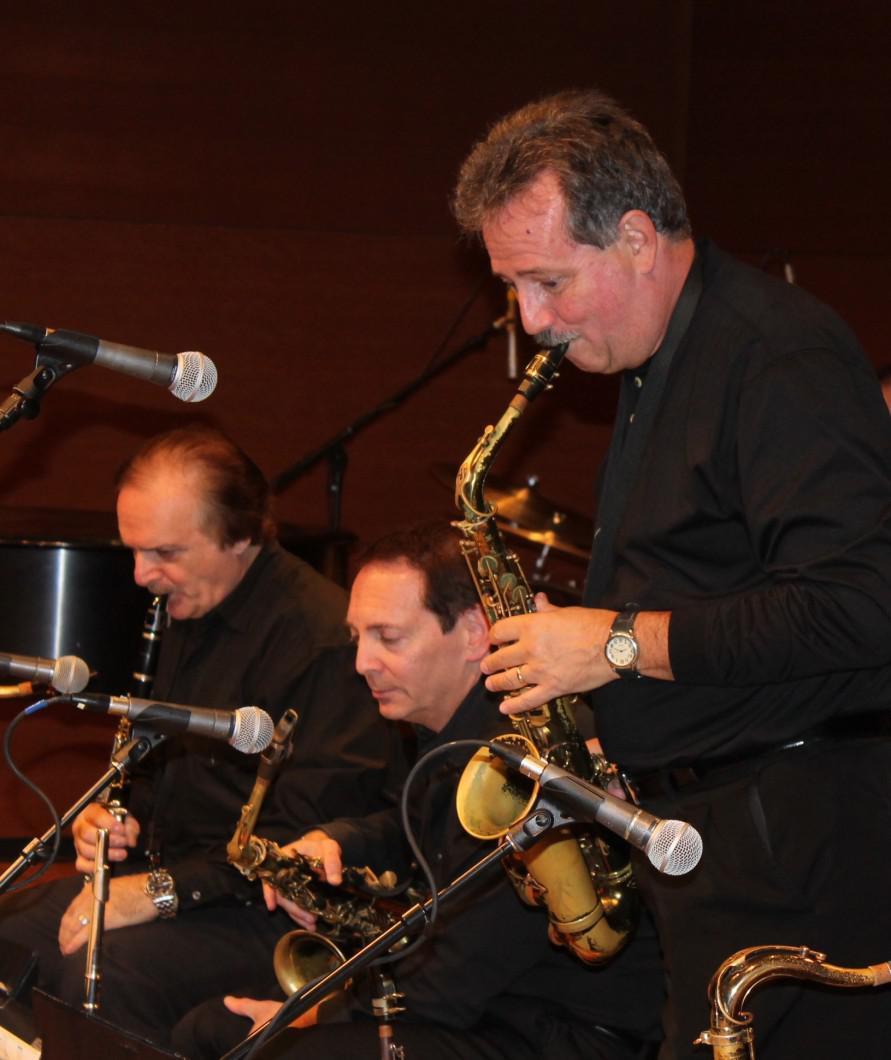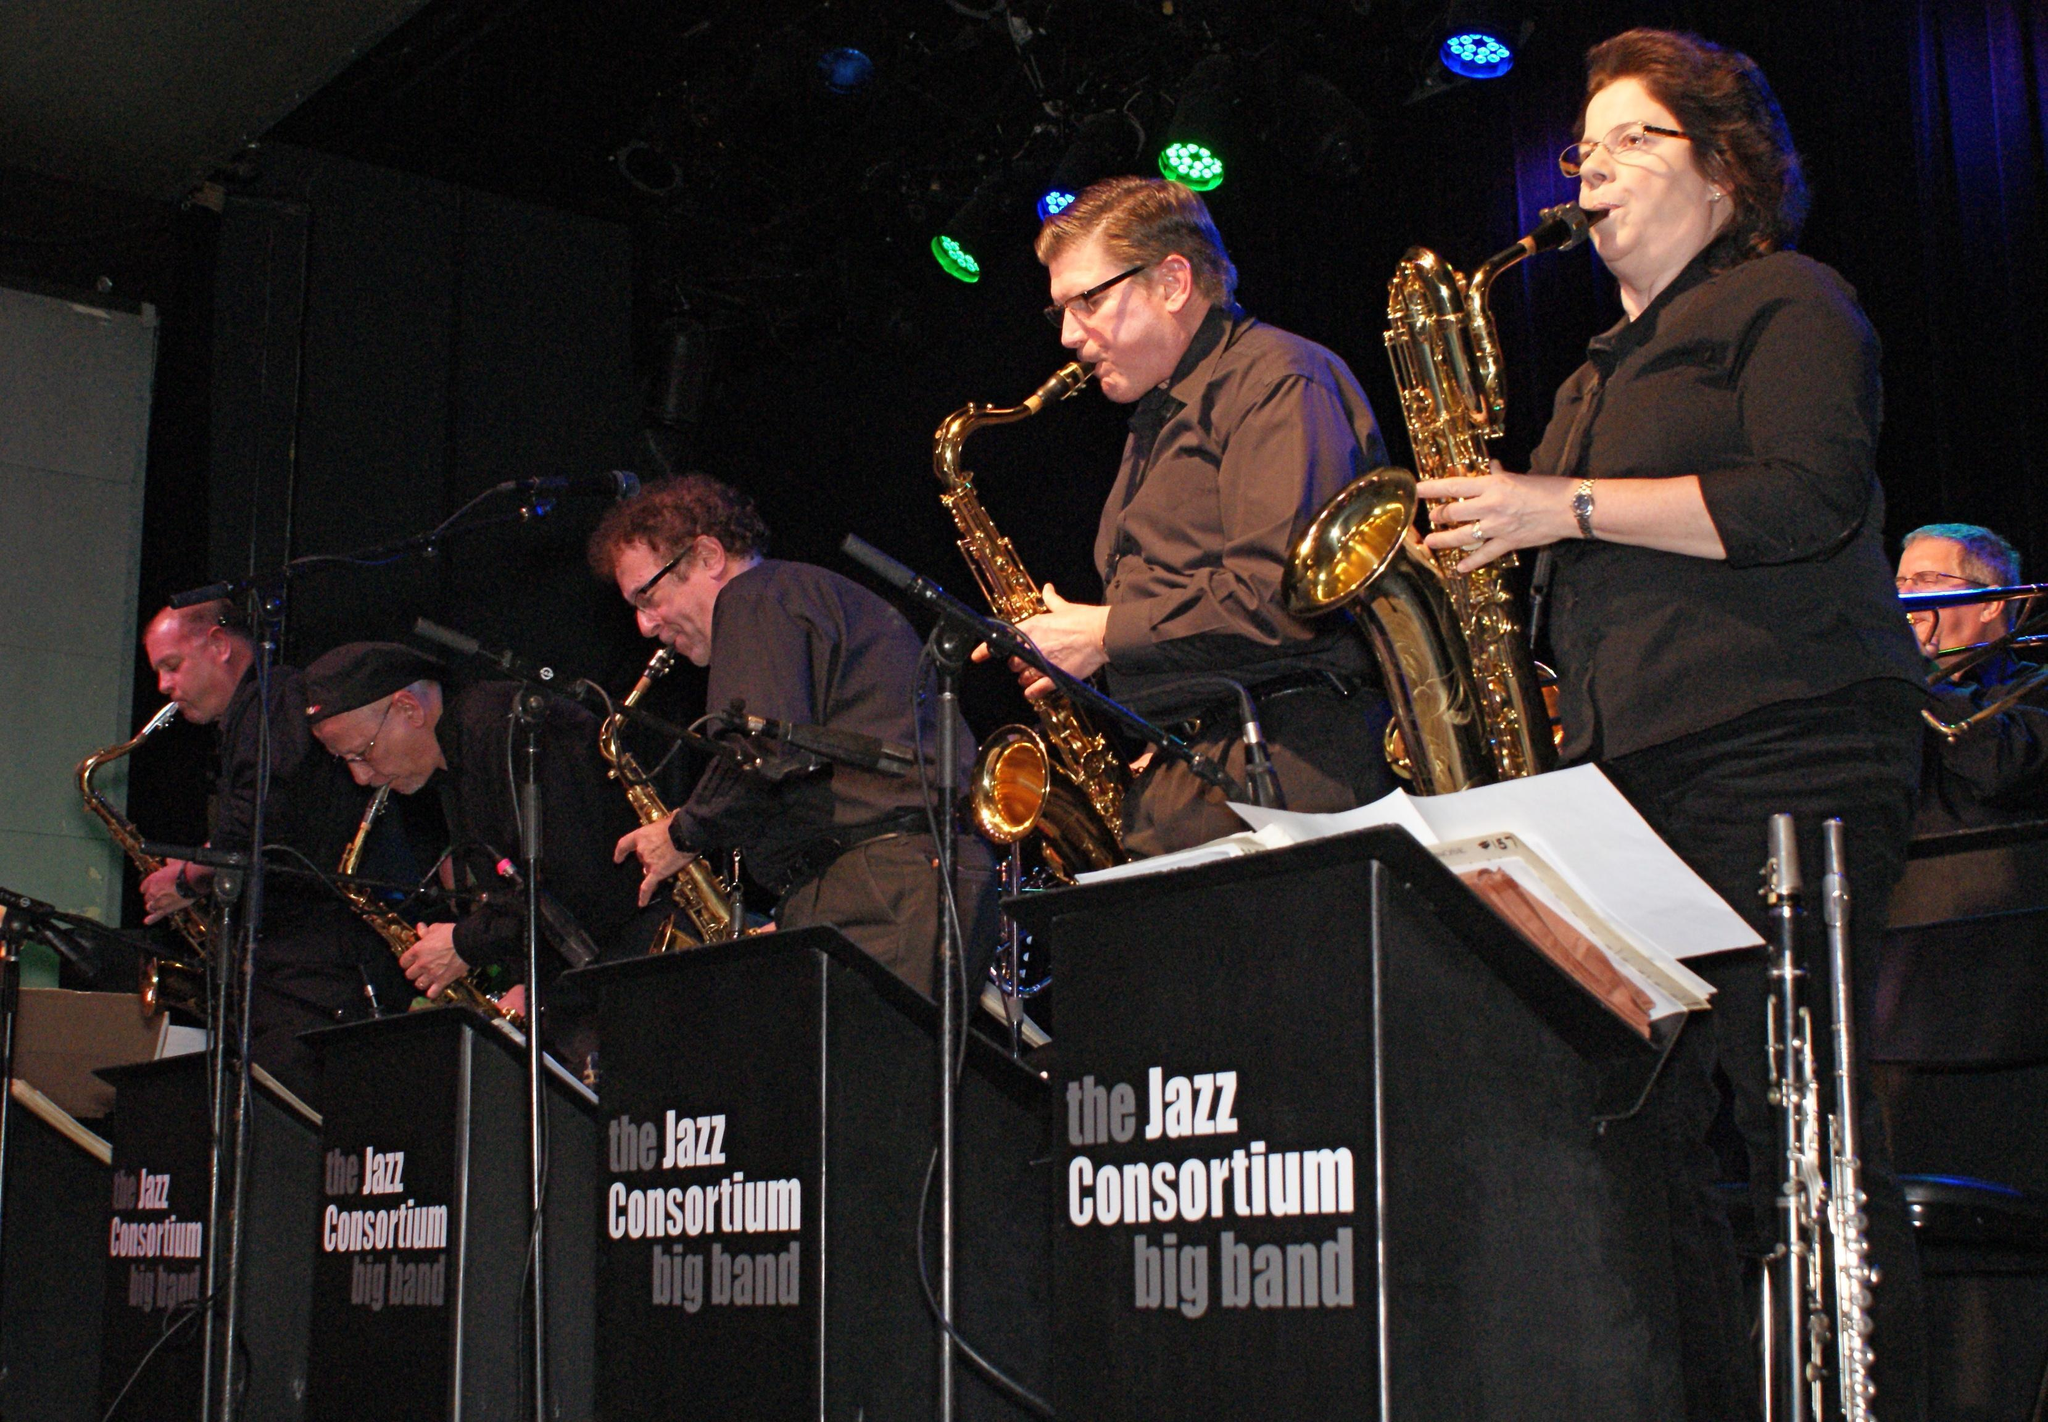The first image is the image on the left, the second image is the image on the right. For the images shown, is this caption "One of the musicians playing a saxophone depicted in the image on the right is a woman." true? Answer yes or no. Yes. 